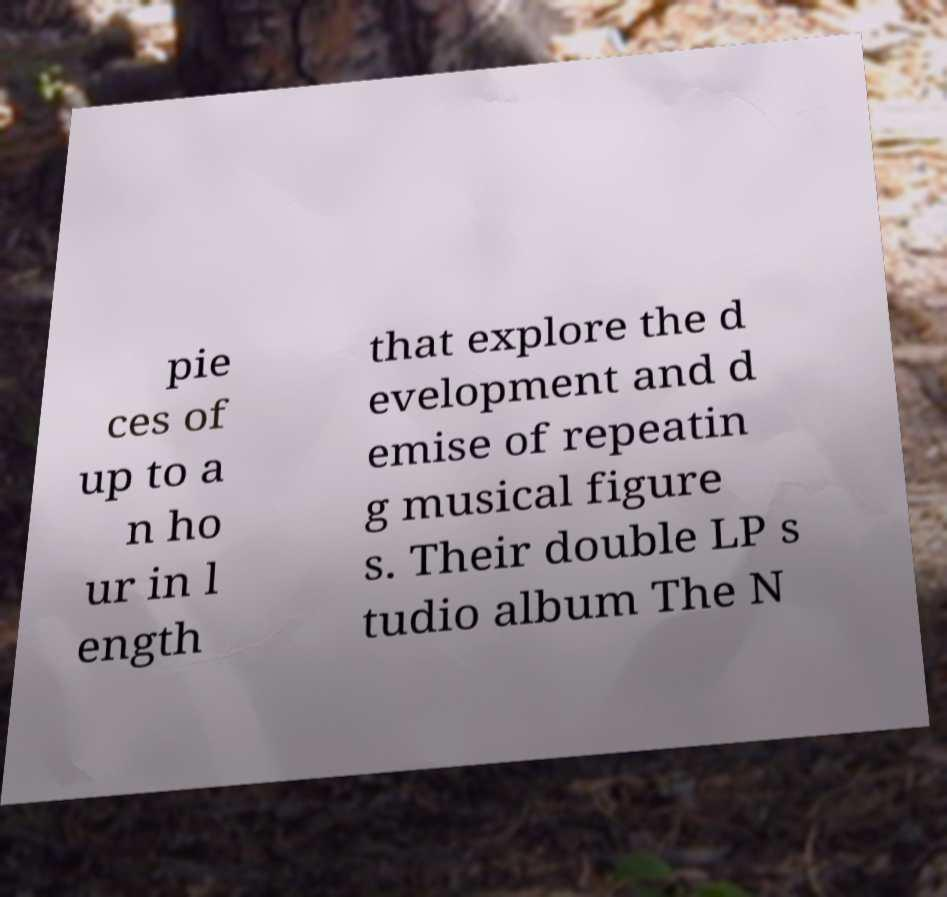Can you accurately transcribe the text from the provided image for me? pie ces of up to a n ho ur in l ength that explore the d evelopment and d emise of repeatin g musical figure s. Their double LP s tudio album The N 